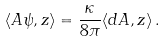<formula> <loc_0><loc_0><loc_500><loc_500>\langle A \psi , z \rangle = \frac { \kappa } { 8 \pi } \langle d A , z \rangle \, .</formula> 